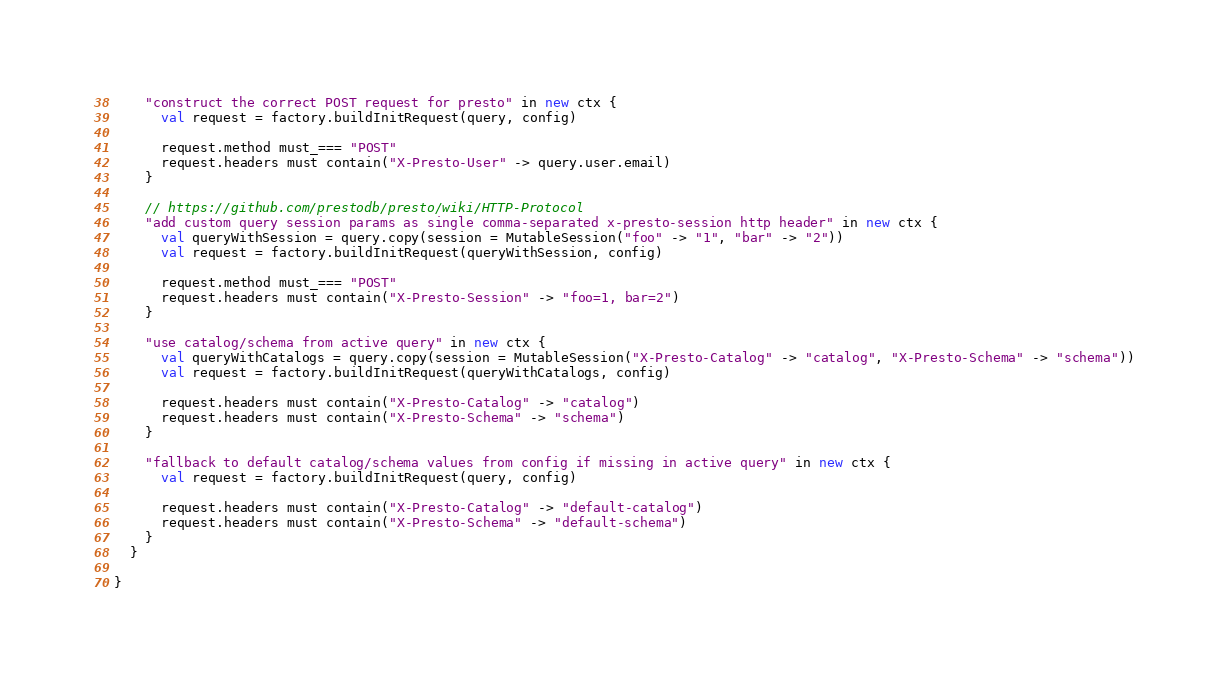<code> <loc_0><loc_0><loc_500><loc_500><_Scala_>    "construct the correct POST request for presto" in new ctx {
      val request = factory.buildInitRequest(query, config)

      request.method must_=== "POST"
      request.headers must contain("X-Presto-User" -> query.user.email)
    }

    // https://github.com/prestodb/presto/wiki/HTTP-Protocol
    "add custom query session params as single comma-separated x-presto-session http header" in new ctx {
      val queryWithSession = query.copy(session = MutableSession("foo" -> "1", "bar" -> "2"))
      val request = factory.buildInitRequest(queryWithSession, config)

      request.method must_=== "POST"
      request.headers must contain("X-Presto-Session" -> "foo=1, bar=2")
    }

    "use catalog/schema from active query" in new ctx {
      val queryWithCatalogs = query.copy(session = MutableSession("X-Presto-Catalog" -> "catalog", "X-Presto-Schema" -> "schema"))
      val request = factory.buildInitRequest(queryWithCatalogs, config)

      request.headers must contain("X-Presto-Catalog" -> "catalog")
      request.headers must contain("X-Presto-Schema" -> "schema")
    }

    "fallback to default catalog/schema values from config if missing in active query" in new ctx {
      val request = factory.buildInitRequest(query, config)

      request.headers must contain("X-Presto-Catalog" -> "default-catalog")
      request.headers must contain("X-Presto-Schema" -> "default-schema")
    }
  }

}
</code> 